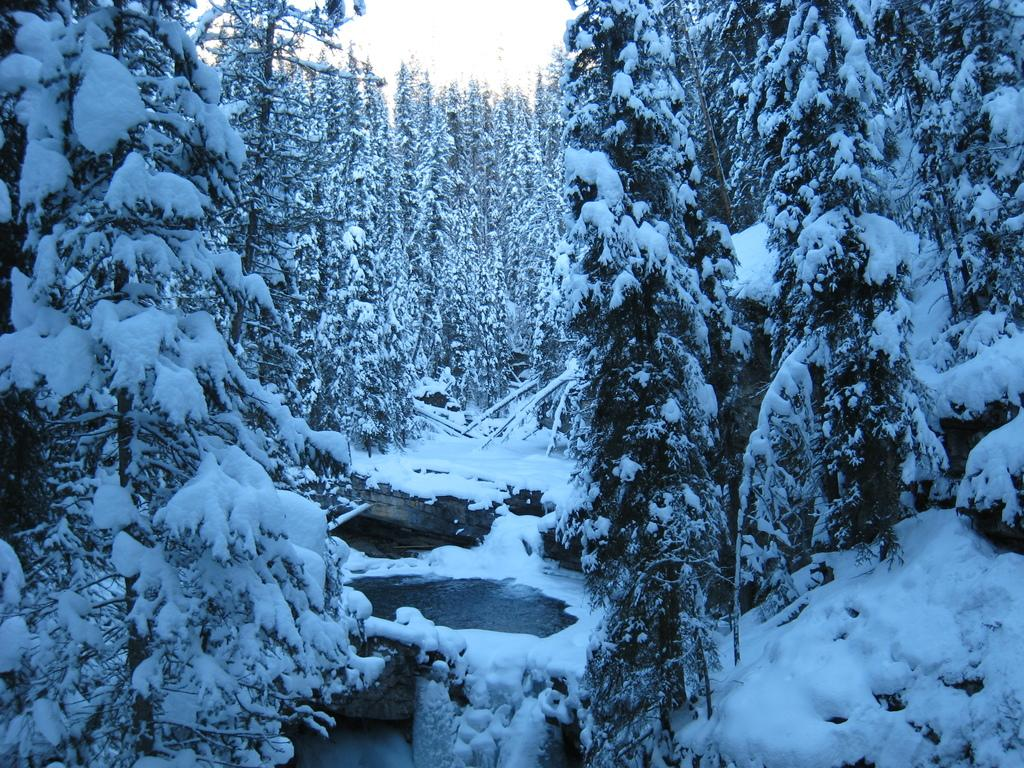What is the main feature of the landscape in the image? There are trees covered with snow in the image. What else can be seen in the image besides the snow-covered trees? There is water visible in the image. What is visible in the background of the image? The sky is visible in the background of the image. What language is spoken by the trees in the image? Trees do not speak any language, so this question cannot be answered. 